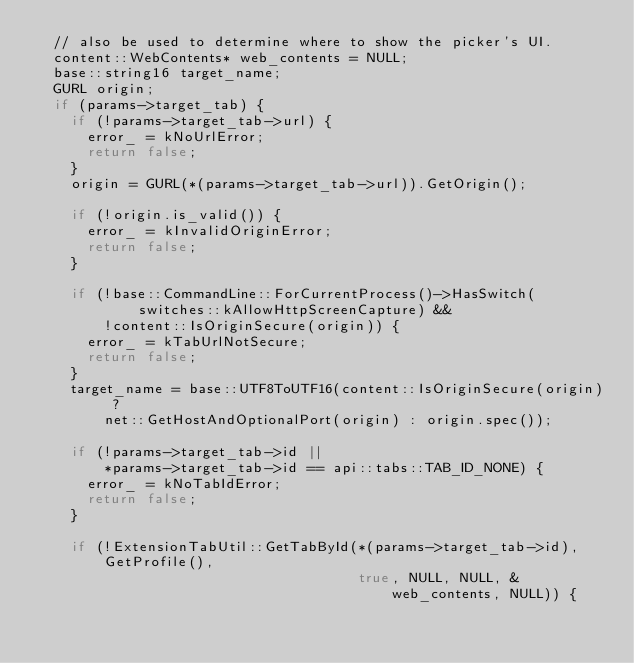<code> <loc_0><loc_0><loc_500><loc_500><_C++_>  // also be used to determine where to show the picker's UI.
  content::WebContents* web_contents = NULL;
  base::string16 target_name;
  GURL origin;
  if (params->target_tab) {
    if (!params->target_tab->url) {
      error_ = kNoUrlError;
      return false;
    }
    origin = GURL(*(params->target_tab->url)).GetOrigin();

    if (!origin.is_valid()) {
      error_ = kInvalidOriginError;
      return false;
    }

    if (!base::CommandLine::ForCurrentProcess()->HasSwitch(
            switches::kAllowHttpScreenCapture) &&
        !content::IsOriginSecure(origin)) {
      error_ = kTabUrlNotSecure;
      return false;
    }
    target_name = base::UTF8ToUTF16(content::IsOriginSecure(origin) ?
        net::GetHostAndOptionalPort(origin) : origin.spec());

    if (!params->target_tab->id ||
        *params->target_tab->id == api::tabs::TAB_ID_NONE) {
      error_ = kNoTabIdError;
      return false;
    }

    if (!ExtensionTabUtil::GetTabById(*(params->target_tab->id), GetProfile(),
                                      true, NULL, NULL, &web_contents, NULL)) {</code> 